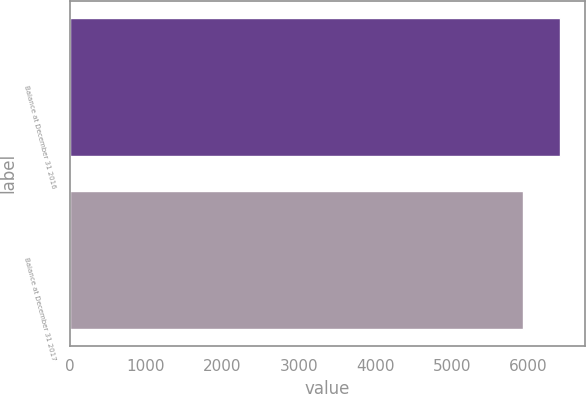Convert chart. <chart><loc_0><loc_0><loc_500><loc_500><bar_chart><fcel>Balance at December 31 2016<fcel>Balance at December 31 2017<nl><fcel>6415.6<fcel>5928.5<nl></chart> 